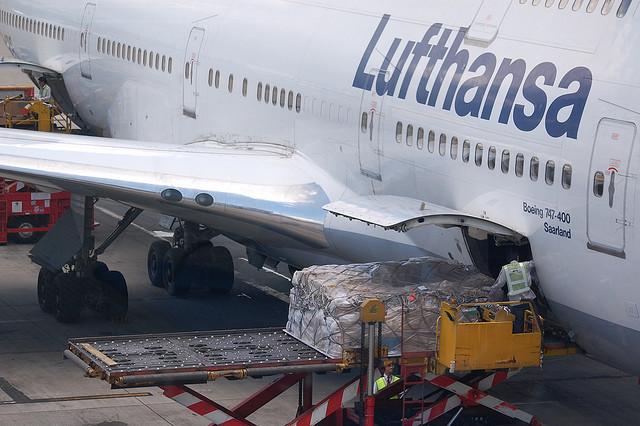What are the small ovals below the logo?
Quick response, please. Windows. How many passenger seats are on this airplane?
Answer briefly. 200. What airline is painting on the side of the plane?
Be succinct. Lufthansa. How many people are in the photo?
Keep it brief. 2. 